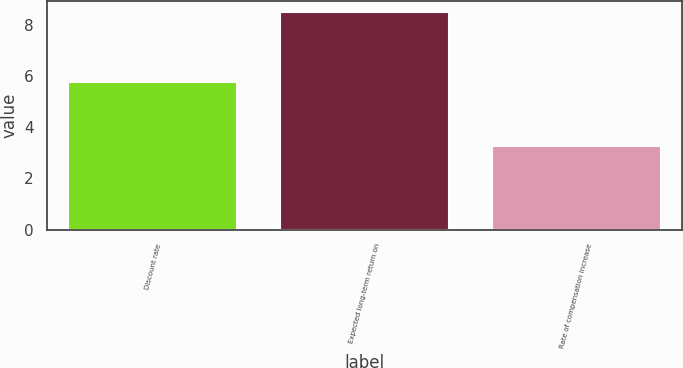<chart> <loc_0><loc_0><loc_500><loc_500><bar_chart><fcel>Discount rate<fcel>Expected long-term return on<fcel>Rate of compensation increase<nl><fcel>5.75<fcel>8.5<fcel>3.25<nl></chart> 